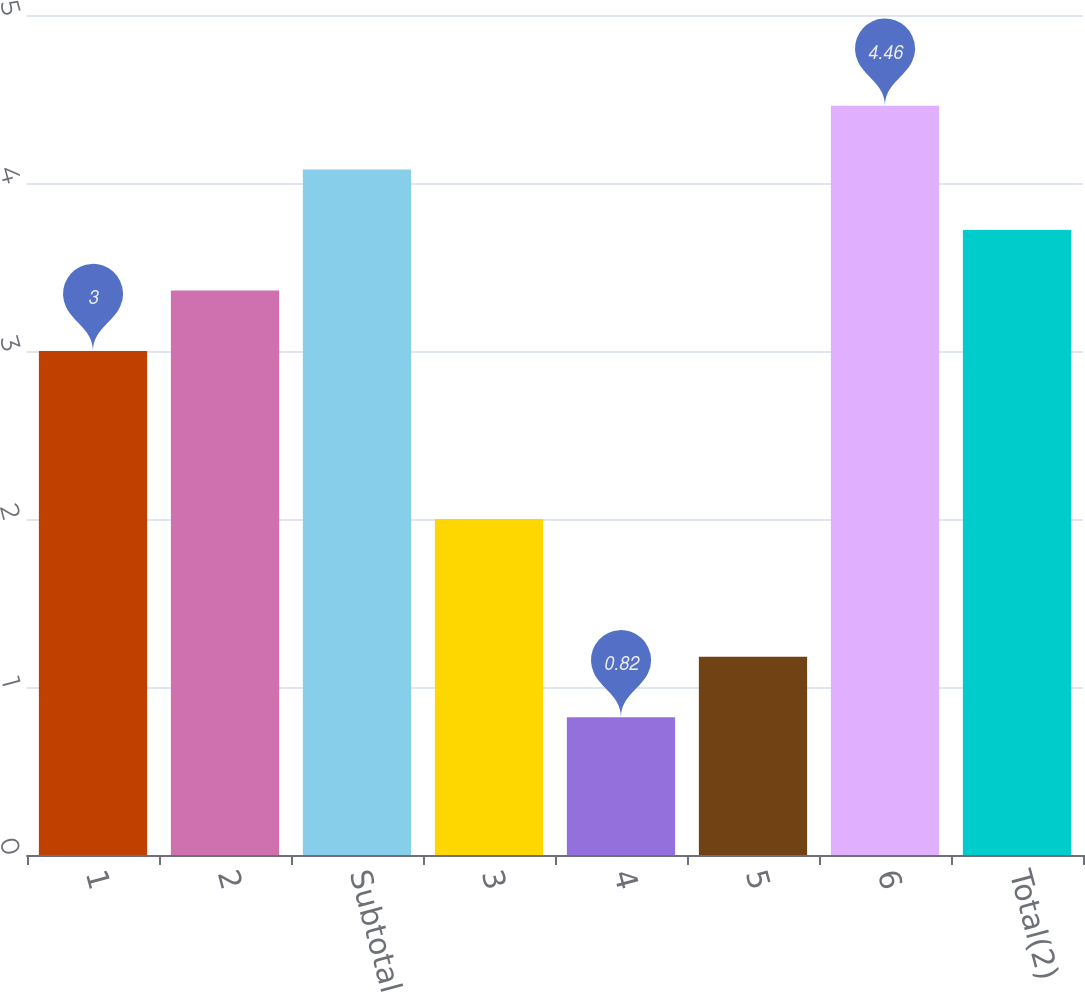Convert chart to OTSL. <chart><loc_0><loc_0><loc_500><loc_500><bar_chart><fcel>1<fcel>2<fcel>Subtotal<fcel>3<fcel>4<fcel>5<fcel>6<fcel>Total(2)<nl><fcel>3<fcel>3.36<fcel>4.08<fcel>2<fcel>0.82<fcel>1.18<fcel>4.46<fcel>3.72<nl></chart> 